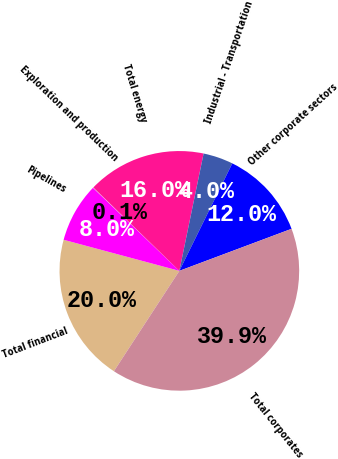<chart> <loc_0><loc_0><loc_500><loc_500><pie_chart><fcel>Total financial<fcel>Pipelines<fcel>Exploration and production<fcel>Total energy<fcel>Industrial - Transportation<fcel>Other corporate sectors<fcel>Total corporates<nl><fcel>19.98%<fcel>8.02%<fcel>0.06%<fcel>15.99%<fcel>4.04%<fcel>12.01%<fcel>39.9%<nl></chart> 